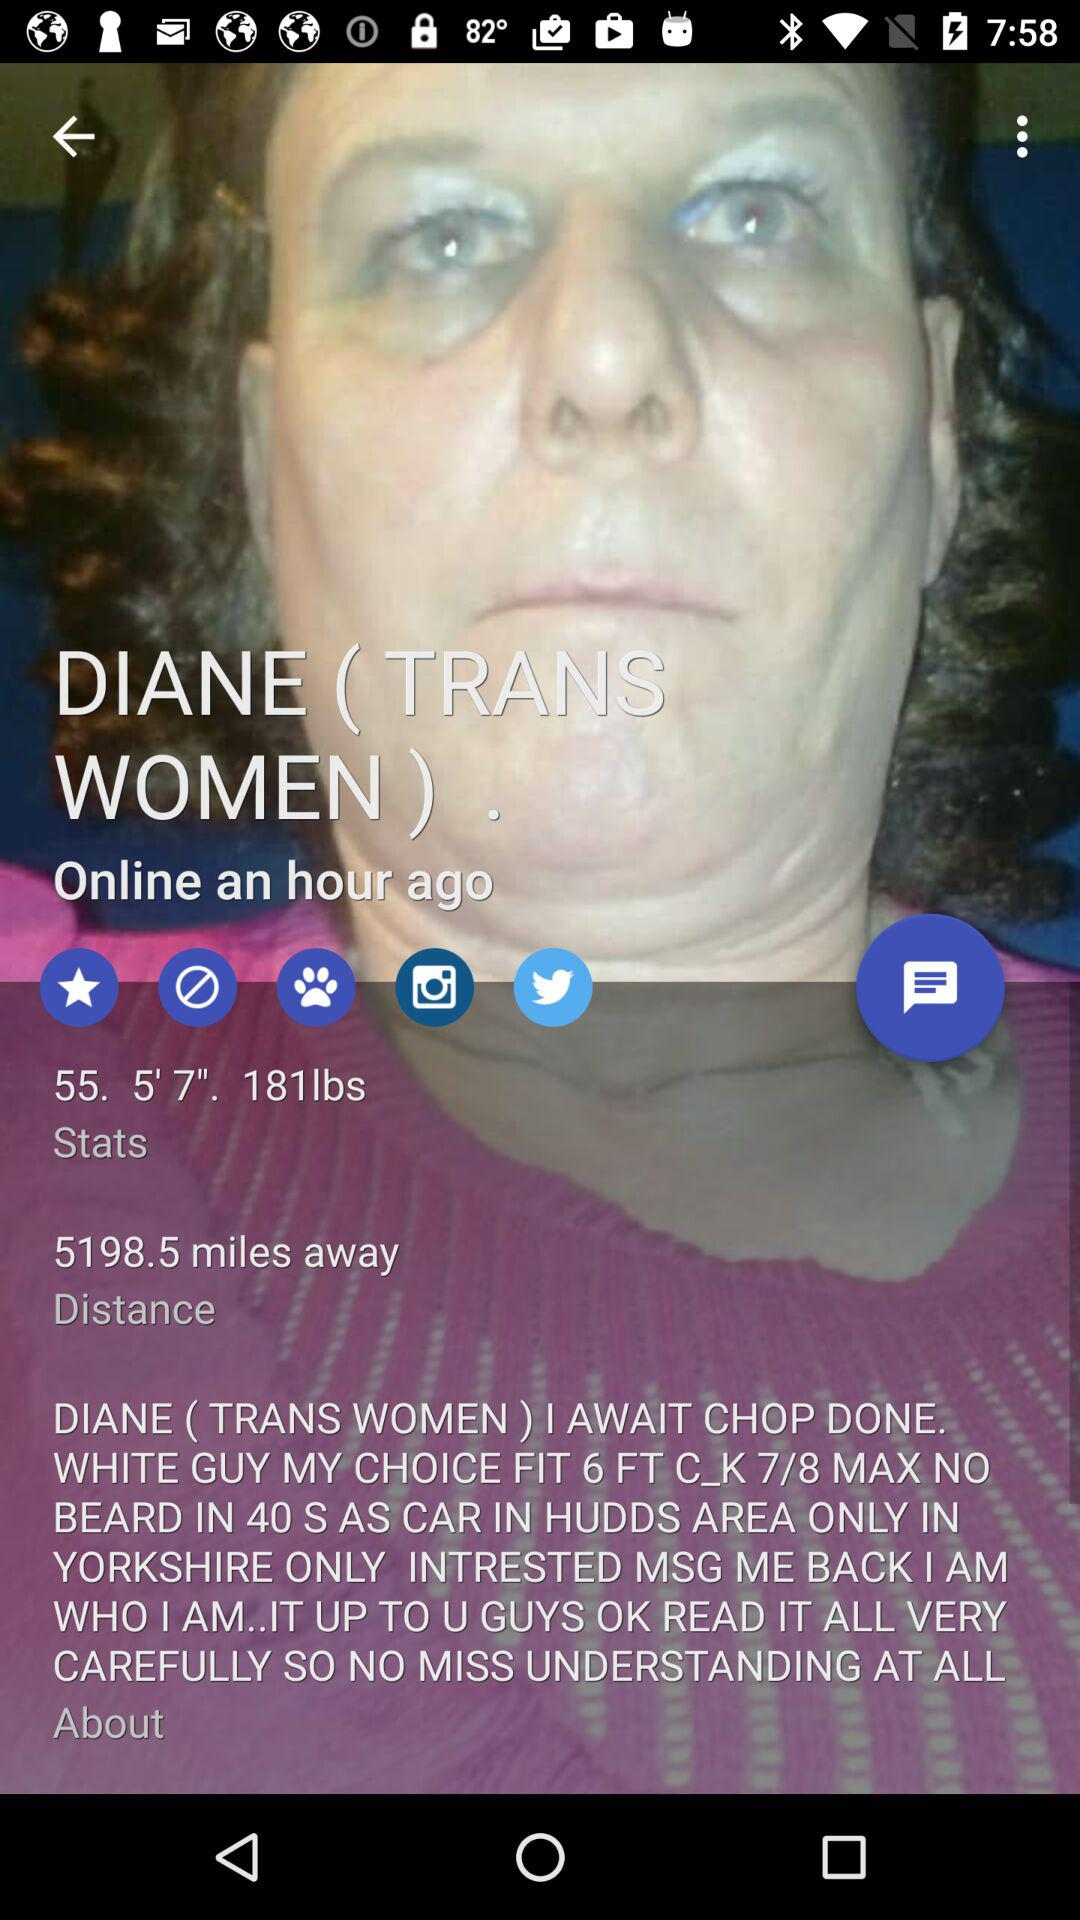What is the distance? The distance is 5198.5 miles. 